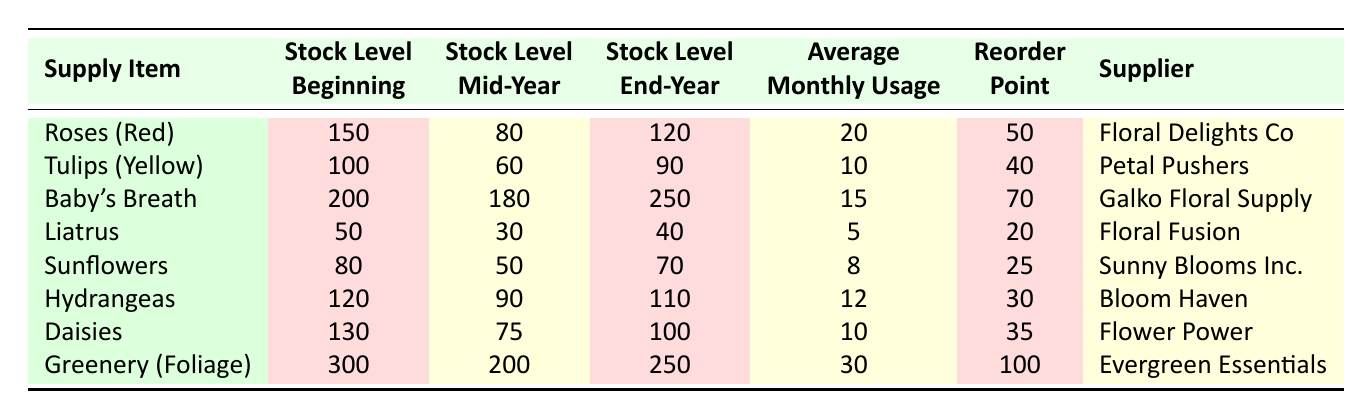What was the stock level of Baby's Breath at mid-year? In the table, under the "Stock Level Mid-Year" column for Baby's Breath, the value is 180.
Answer: 180 Which supply item has the highest average monthly usage? By comparing the "Average Monthly Usage" column, Greenery (Foliage) has the highest value at 30.
Answer: Greenery (Foliage) Did the stock level of Liatrus decrease from the beginning to the end of the year? The stock level at the beginning of the year is 50, and it ended at 40, which is a decrease.
Answer: Yes What is the total average monthly usage for Roses (Red) and Daisies combined? The average monthly usage for Roses (Red) is 20 and for Daisies is 10. Adding these together gives 20 + 10 = 30.
Answer: 30 What is the reorder point for Tulips (Yellow)? The table shows the reorder point for Tulips (Yellow) as 40.
Answer: 40 Is the stock level of Sunflowers at the end of the year greater than its beginning of the year stock level? The stock level at the beginning of the year is 80, and it ended at 70, which means it is not greater.
Answer: No Calculate the difference in stock levels of Greenery (Foliage) from the beginning to mid-year. The beginning stock level is 300 and mid-year stock level is 200. The difference is 300 - 200 = 100.
Answer: 100 Which supplier provided the least amount of stock by the end of the year? By comparing the stock levels at the end of the year, Liatrus has the lowest stock level at 40.
Answer: Floral Fusion How many total stock levels are below the reorder point across all items? Checking all items' stock levels against the reorder points, Roses (Red), Liatrus, Sunflowers, and Tulips (Yellow) all fall below. Counting these gives a total of 4 items.
Answer: 4 If we take an average of the stock levels at the end of the year, what is it? The end-year stock levels are 120, 90, 250, 40, 70, 110, 100, and 250. Adding them gives 1030, and dividing by the number of items (8) results in 1030/8 = 128.75.
Answer: 128.75 